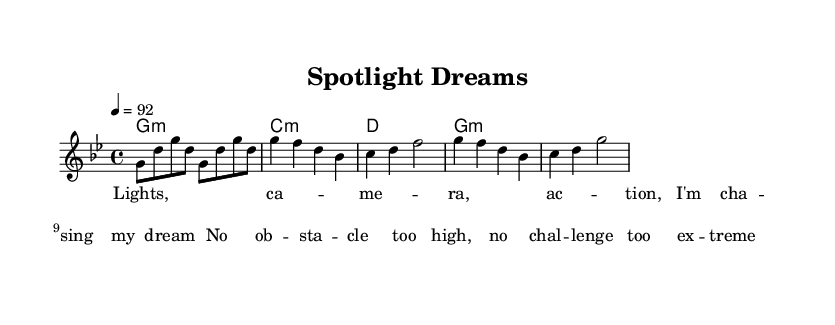What is the key signature of this music? The key signature is G minor, which has two flats: B-flat and E-flat. This can be determined by looking at the key indication at the beginning of the sheet music, which specifies G minor.
Answer: G minor What is the time signature? The time signature is 4/4, meaning there are four beats per measure, and each quarter note gets one beat. This is indicated at the beginning of the score.
Answer: 4/4 What is the tempo marking for this piece? The tempo marking is 92 beats per minute, specified as "4 = 92". This detail indicates the pace at which the music should be played.
Answer: 92 How many measures are in the chorus section as shown? The chorus section consists of four measures, as evidenced by the layout of the notes grouped together which align with the measure bars on the sheet music.
Answer: 4 What type of musical form does this rap track represent? The rap track follows a structured form typical in modern rap, focusing on verses, chorus, and a motivational theme about overcoming obstacles. The lyrics and melody suggest a repeating cycle commonly found in rap music.
Answer: Structured form What is the overall theme expressed in the lyrics? The overall theme is about ambition and perseverance, highlighting a commitment to chasing dreams despite challenges. This theme is evident in the lyric "No obstacle too high, no challenge too extreme."
Answer: Ambition What type of chords are used in the harmony? The harmony primarily uses minor chords, specifically G minor and C minor, suggesting a sound that conveys depth and emotion—a common attribute in motivational rap music.
Answer: Minor chords 